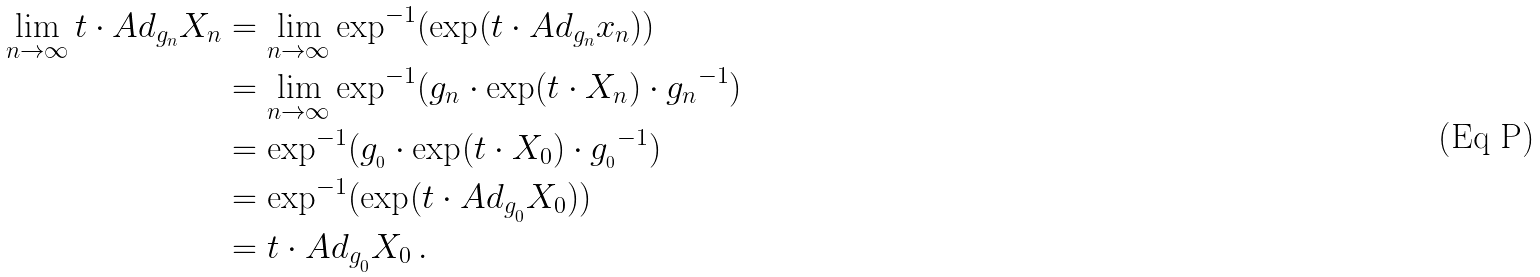Convert formula to latex. <formula><loc_0><loc_0><loc_500><loc_500>\lim _ { n \rightarrow \infty } t \cdot A d _ { g _ { n } } X _ { n } & = \lim _ { n \rightarrow \infty } \text {exp} ^ { - 1 } ( \text {exp} ( t \cdot A d _ { g _ { n } } x _ { n } ) ) \\ & = \lim _ { n \rightarrow \infty } \text {exp} ^ { - 1 } ( g _ { n } \cdot \text {exp} ( t \cdot X _ { n } ) \cdot { g _ { n } } ^ { - 1 } ) \\ & = \text {exp} ^ { - 1 } ( g _ { _ { 0 } } \cdot \text {exp} ( t \cdot X _ { 0 } ) \cdot { g _ { _ { 0 } } } ^ { - 1 } ) \\ & = \text {exp} ^ { - 1 } ( \text {exp} ( t \cdot A d _ { g _ { _ { 0 } } } X _ { 0 } ) ) \\ & = t \cdot A d _ { g _ { _ { 0 } } } X _ { 0 } \, .</formula> 